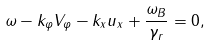<formula> <loc_0><loc_0><loc_500><loc_500>\omega - k _ { \varphi } V _ { \varphi } - k _ { x } u _ { x } + \frac { \omega _ { B } } { \gamma _ { r } } = 0 ,</formula> 